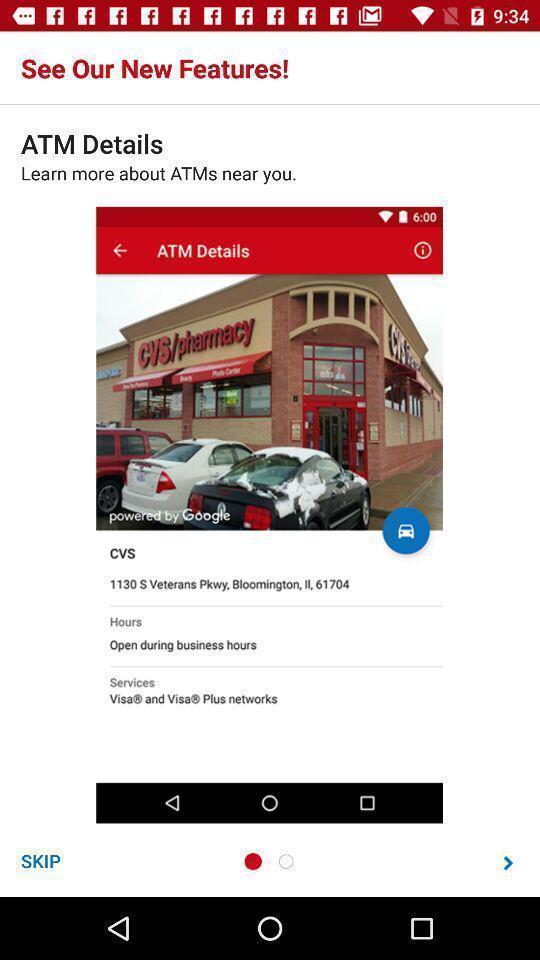Describe the content in this image. Welcome page of a banking app. 